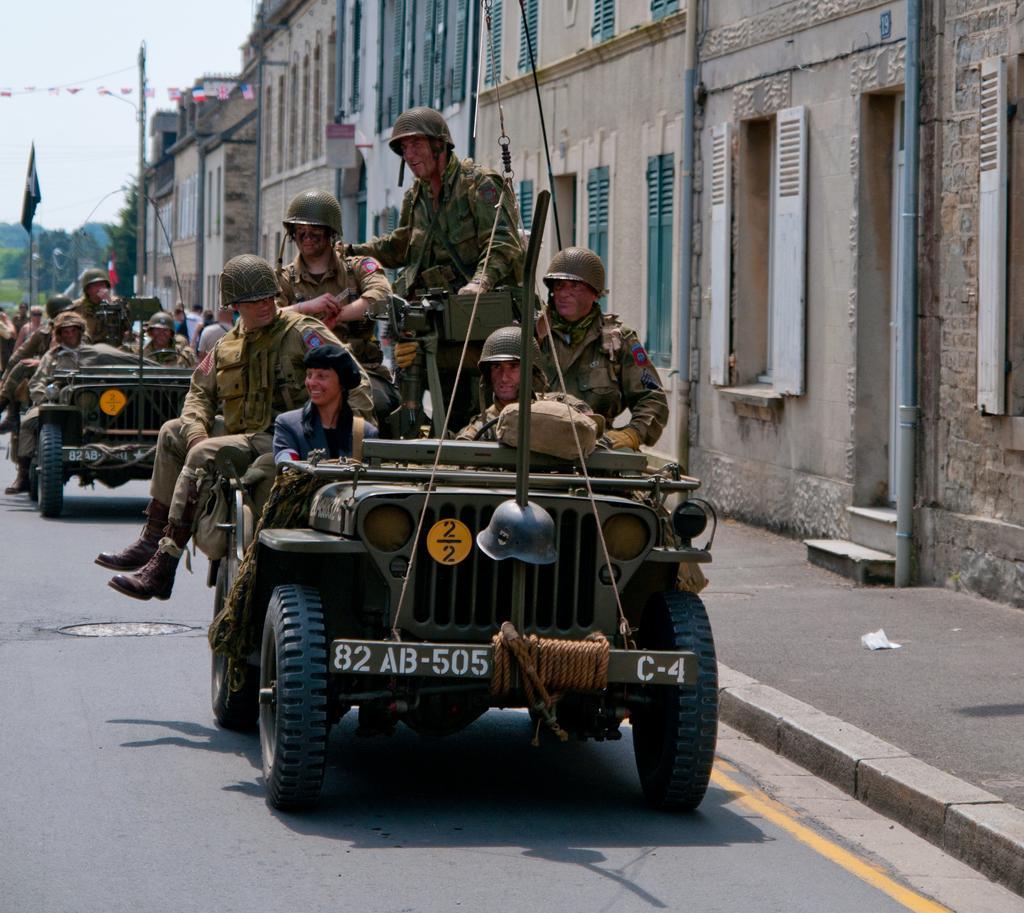In one or two sentences, can you explain what this image depicts? In this picture there are soldiers in the jeep in the center of the image and there are other jeeps in the image and there are buildings and trees in the background area of the image. 